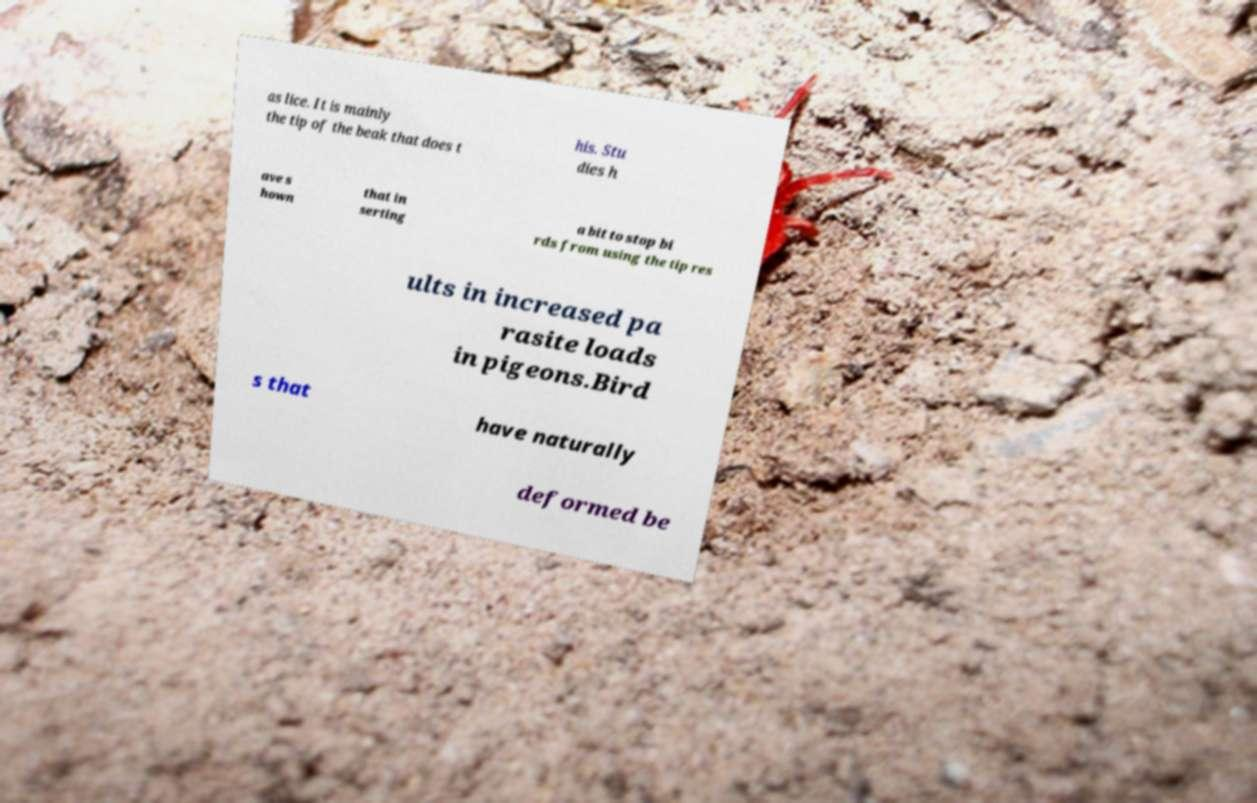Please identify and transcribe the text found in this image. as lice. It is mainly the tip of the beak that does t his. Stu dies h ave s hown that in serting a bit to stop bi rds from using the tip res ults in increased pa rasite loads in pigeons.Bird s that have naturally deformed be 